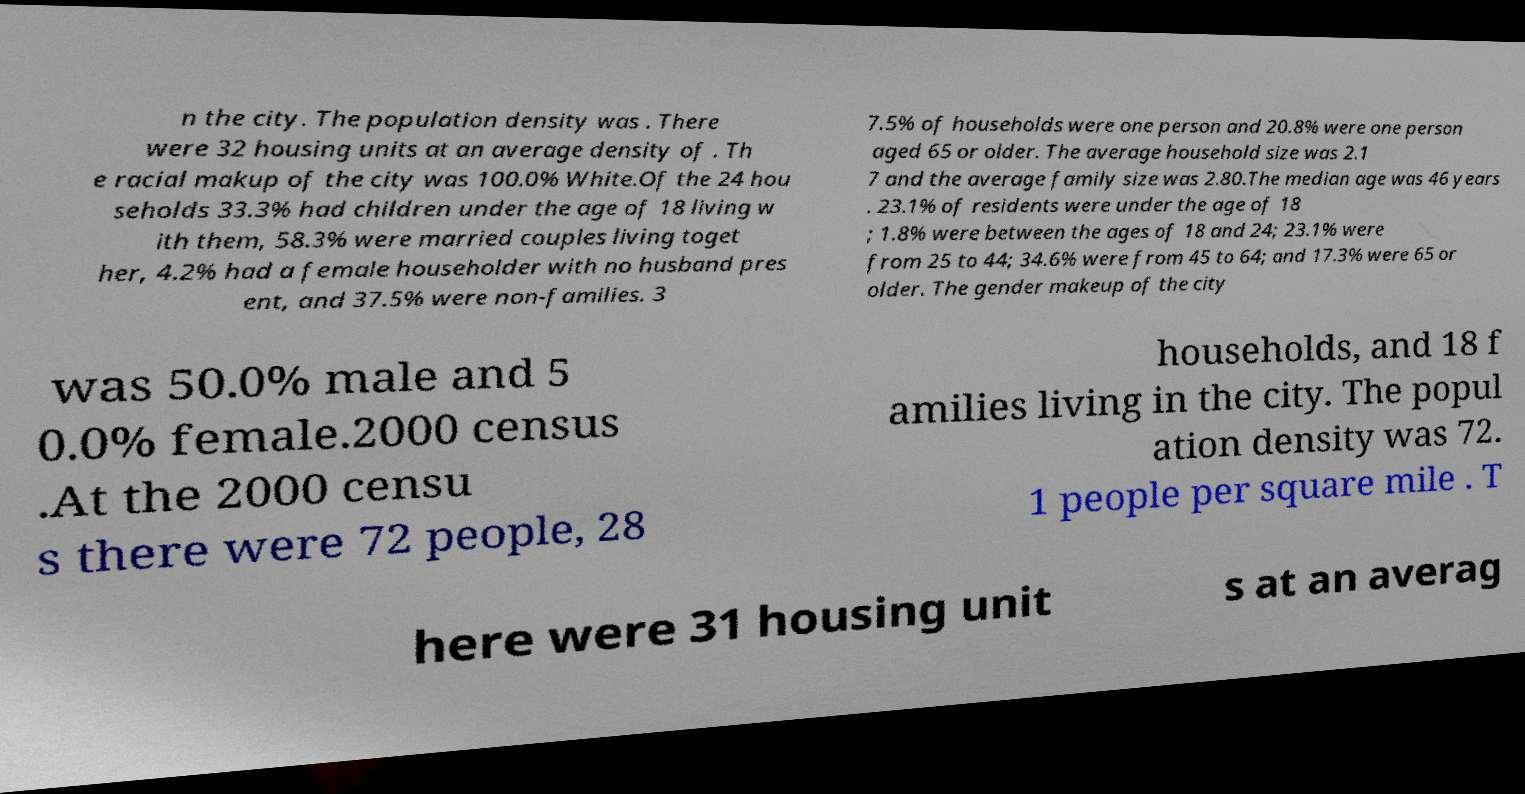Can you read and provide the text displayed in the image?This photo seems to have some interesting text. Can you extract and type it out for me? n the city. The population density was . There were 32 housing units at an average density of . Th e racial makup of the city was 100.0% White.Of the 24 hou seholds 33.3% had children under the age of 18 living w ith them, 58.3% were married couples living toget her, 4.2% had a female householder with no husband pres ent, and 37.5% were non-families. 3 7.5% of households were one person and 20.8% were one person aged 65 or older. The average household size was 2.1 7 and the average family size was 2.80.The median age was 46 years . 23.1% of residents were under the age of 18 ; 1.8% were between the ages of 18 and 24; 23.1% were from 25 to 44; 34.6% were from 45 to 64; and 17.3% were 65 or older. The gender makeup of the city was 50.0% male and 5 0.0% female.2000 census .At the 2000 censu s there were 72 people, 28 households, and 18 f amilies living in the city. The popul ation density was 72. 1 people per square mile . T here were 31 housing unit s at an averag 